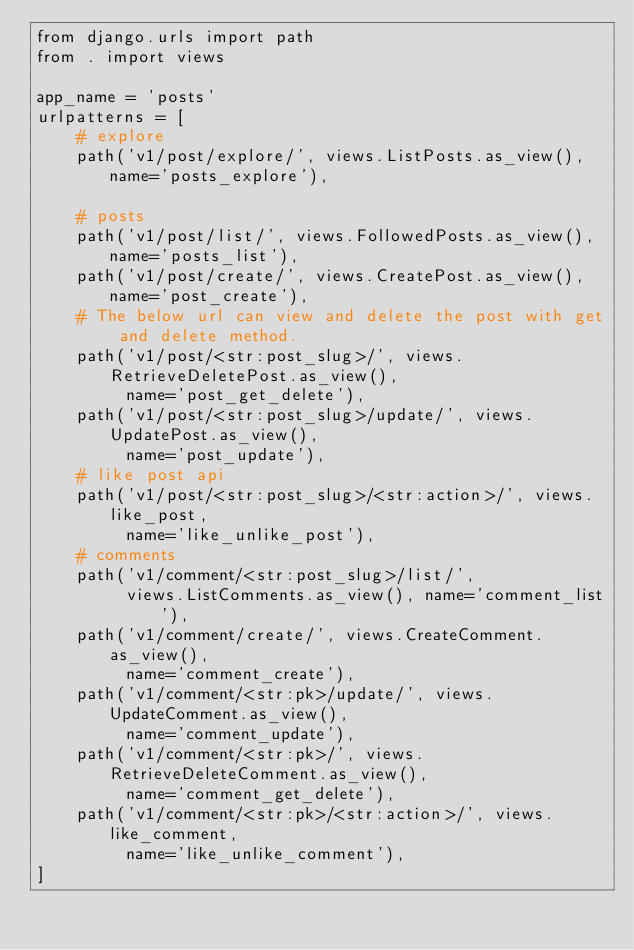Convert code to text. <code><loc_0><loc_0><loc_500><loc_500><_Python_>from django.urls import path
from . import views

app_name = 'posts'
urlpatterns = [
    # explore
    path('v1/post/explore/', views.ListPosts.as_view(), name='posts_explore'),

    # posts
    path('v1/post/list/', views.FollowedPosts.as_view(), name='posts_list'),
    path('v1/post/create/', views.CreatePost.as_view(), name='post_create'),
    # The below url can view and delete the post with get and delete method.
    path('v1/post/<str:post_slug>/', views.RetrieveDeletePost.as_view(),
         name='post_get_delete'),
    path('v1/post/<str:post_slug>/update/', views.UpdatePost.as_view(),
         name='post_update'),
    # like post api
    path('v1/post/<str:post_slug>/<str:action>/', views.like_post,
         name='like_unlike_post'),
    # comments
    path('v1/comment/<str:post_slug>/list/',
         views.ListComments.as_view(), name='comment_list'),
    path('v1/comment/create/', views.CreateComment.as_view(),
         name='comment_create'),
    path('v1/comment/<str:pk>/update/', views.UpdateComment.as_view(),
         name='comment_update'),
    path('v1/comment/<str:pk>/', views.RetrieveDeleteComment.as_view(),
         name='comment_get_delete'),
    path('v1/comment/<str:pk>/<str:action>/', views.like_comment,
         name='like_unlike_comment'),
]
</code> 